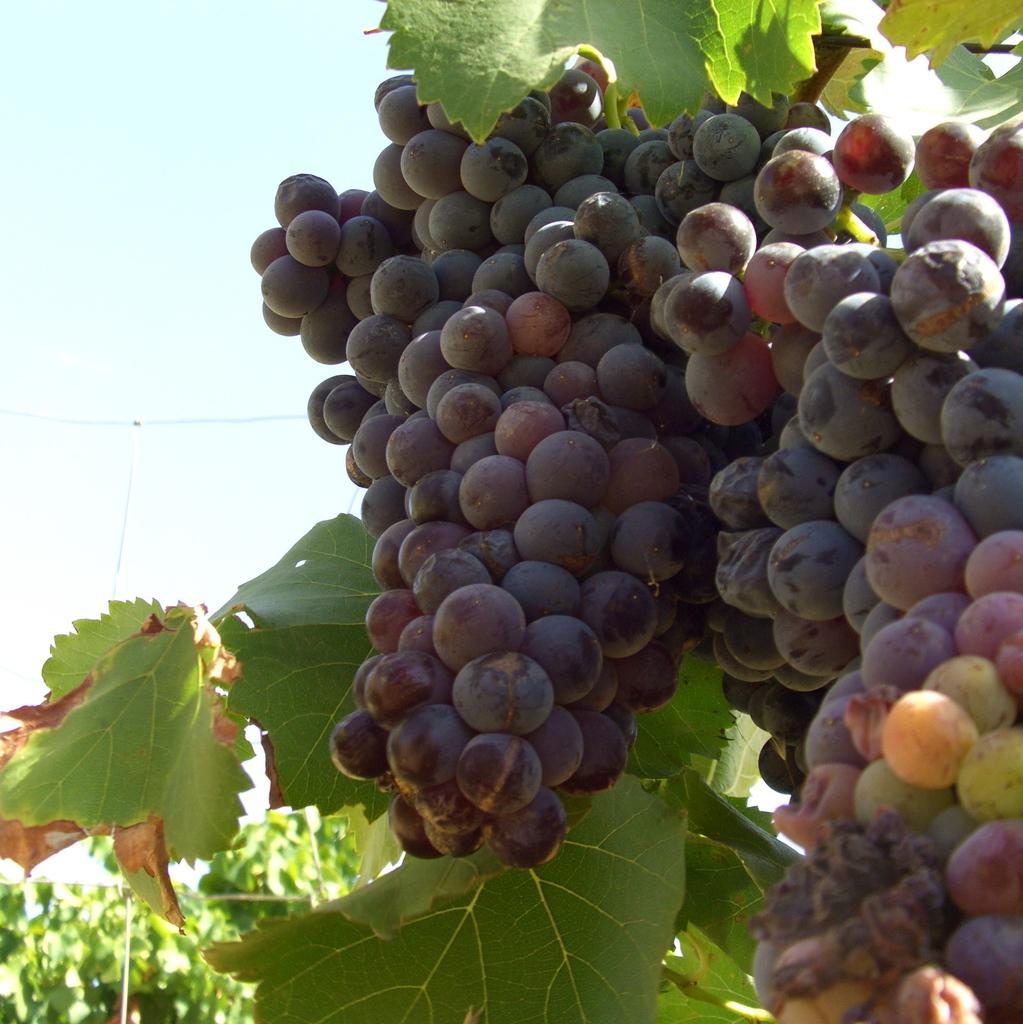What type of fruit is in the image? There is a bunch of grapes in the image. What color are the grapes? The grapes are black in color. What is the source of the grapes in the image? There is a grape plant in the image. What can be seen in the background of the image? Plants and the sky are visible in the background of the image. What type of hammer is being used to organize the rings in the image? There is no hammer or rings present in the image; it features a bunch of black grapes and a grape plant. 